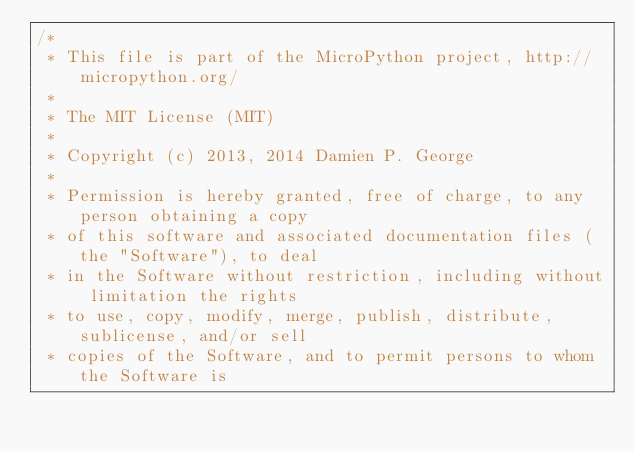Convert code to text. <code><loc_0><loc_0><loc_500><loc_500><_C_>/*
 * This file is part of the MicroPython project, http://micropython.org/
 *
 * The MIT License (MIT)
 *
 * Copyright (c) 2013, 2014 Damien P. George
 *
 * Permission is hereby granted, free of charge, to any person obtaining a copy
 * of this software and associated documentation files (the "Software"), to deal
 * in the Software without restriction, including without limitation the rights
 * to use, copy, modify, merge, publish, distribute, sublicense, and/or sell
 * copies of the Software, and to permit persons to whom the Software is</code> 